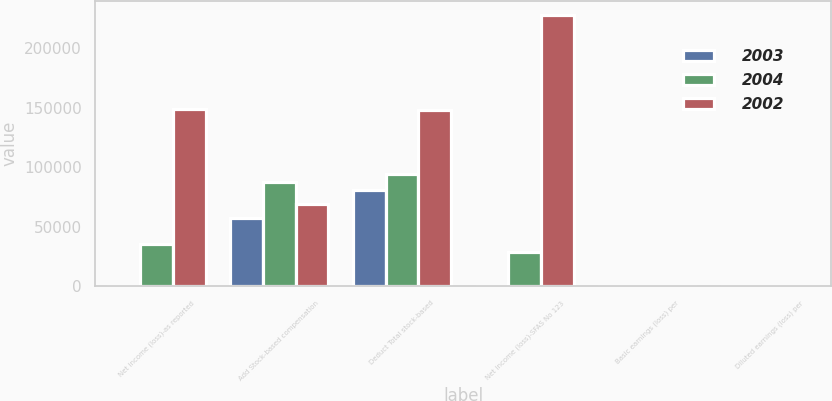<chart> <loc_0><loc_0><loc_500><loc_500><stacked_bar_chart><ecel><fcel>Net income (loss)-as reported<fcel>Add Stock-based compensation<fcel>Deduct Total stock-based<fcel>Net income (loss)-SFAS No 123<fcel>Basic earnings (loss) per<fcel>Diluted earnings (loss) per<nl><fcel>2003<fcel>1.42<fcel>57702<fcel>81166<fcel>1.42<fcel>1.39<fcel>1.33<nl><fcel>2004<fcel>35282<fcel>87751<fcel>94525<fcel>28508<fcel>0.07<fcel>0.07<nl><fcel>2002<fcel>149132<fcel>68927<fcel>148083<fcel>228288<fcel>0.6<fcel>0.6<nl></chart> 